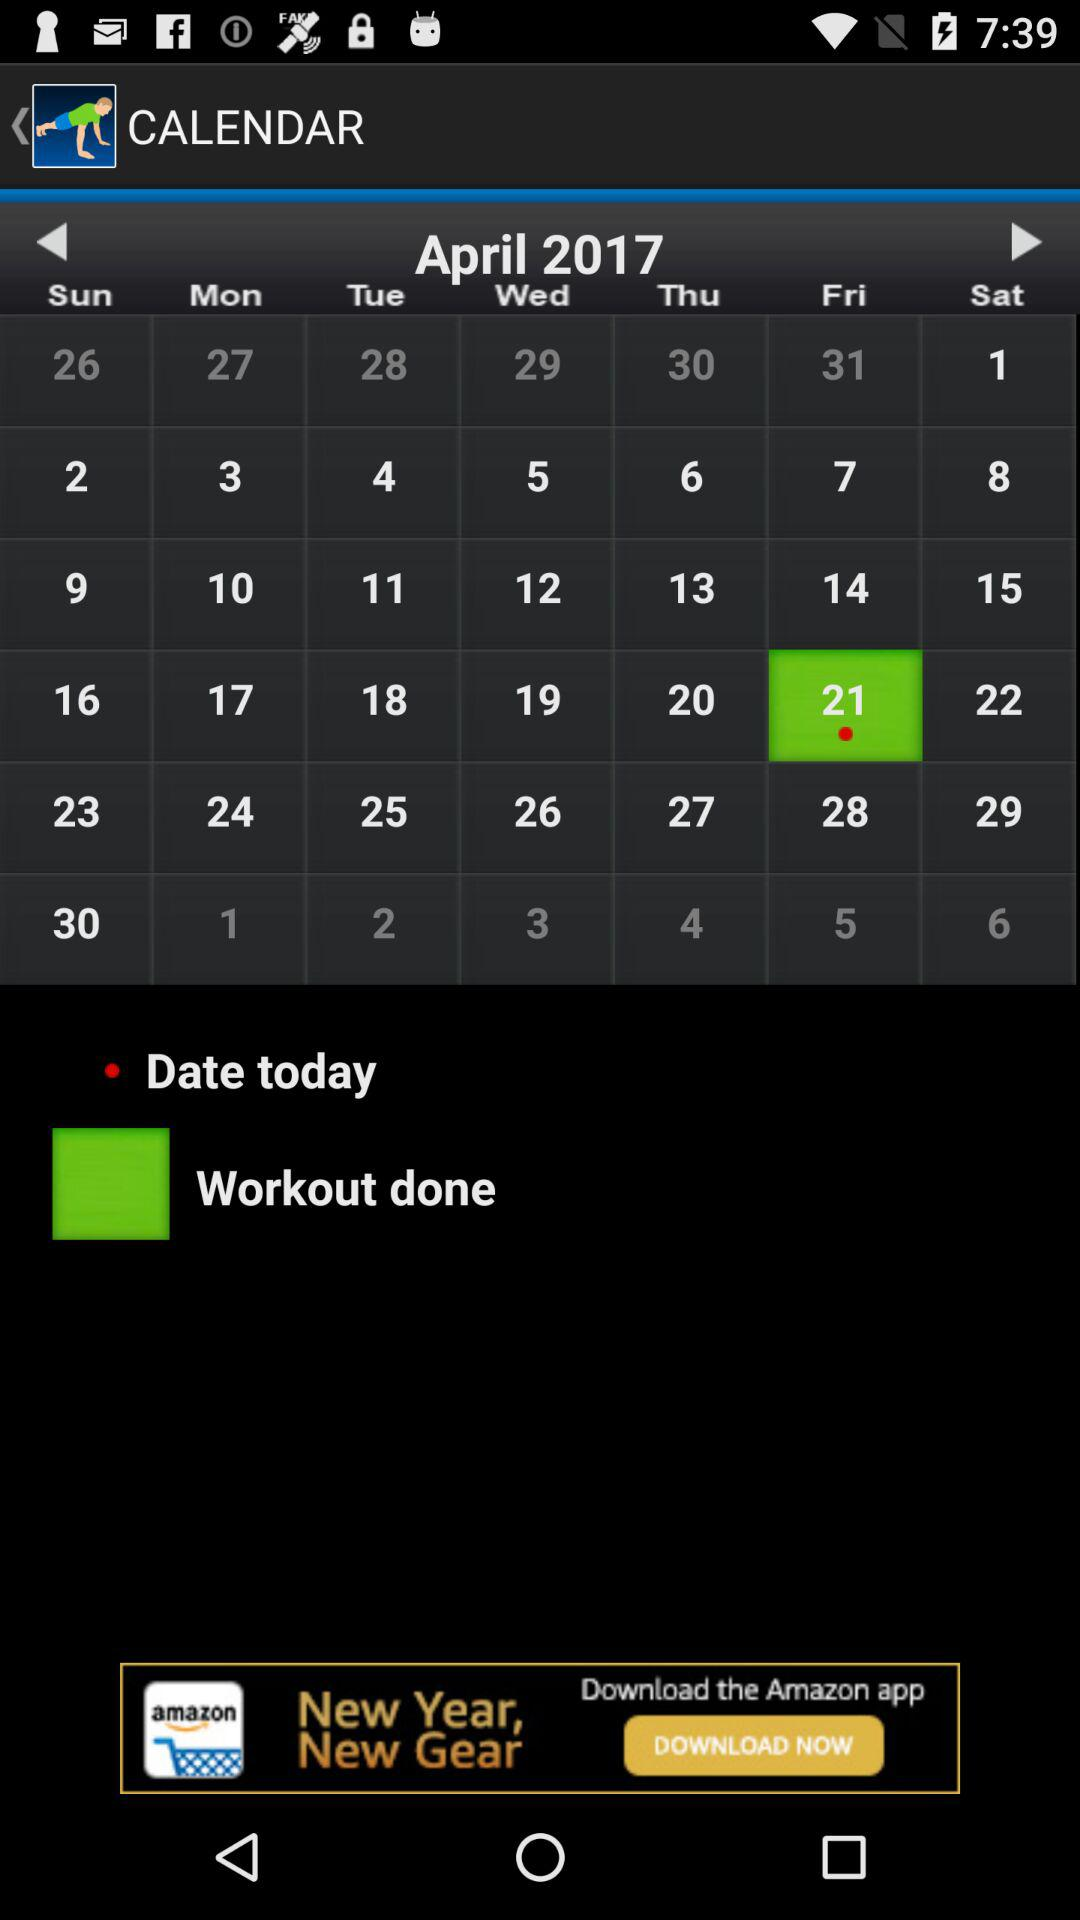How many dates are there in April 2017?
Answer the question using a single word or phrase. 30 